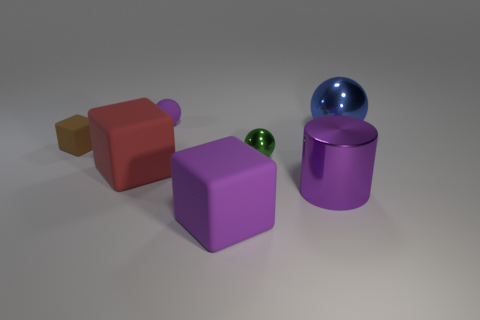Add 1 large cyan matte balls. How many objects exist? 8 Subtract all blocks. How many objects are left? 4 Add 3 small blue metallic cylinders. How many small blue metallic cylinders exist? 3 Subtract 0 red balls. How many objects are left? 7 Subtract all small green cubes. Subtract all brown things. How many objects are left? 6 Add 5 purple cylinders. How many purple cylinders are left? 6 